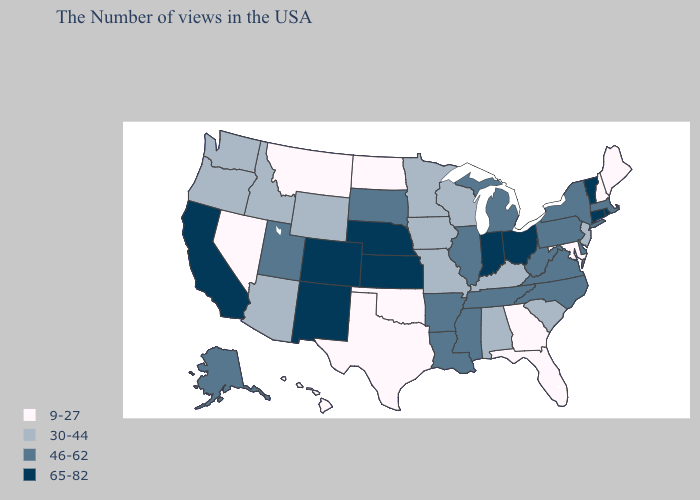What is the lowest value in the West?
Keep it brief. 9-27. Name the states that have a value in the range 46-62?
Write a very short answer. Massachusetts, New York, Delaware, Pennsylvania, Virginia, North Carolina, West Virginia, Michigan, Tennessee, Illinois, Mississippi, Louisiana, Arkansas, South Dakota, Utah, Alaska. Which states hav the highest value in the MidWest?
Keep it brief. Ohio, Indiana, Kansas, Nebraska. Name the states that have a value in the range 9-27?
Answer briefly. Maine, New Hampshire, Maryland, Florida, Georgia, Oklahoma, Texas, North Dakota, Montana, Nevada, Hawaii. What is the value of Wyoming?
Give a very brief answer. 30-44. Name the states that have a value in the range 65-82?
Answer briefly. Rhode Island, Vermont, Connecticut, Ohio, Indiana, Kansas, Nebraska, Colorado, New Mexico, California. Does Kansas have the highest value in the MidWest?
Write a very short answer. Yes. Which states have the lowest value in the USA?
Short answer required. Maine, New Hampshire, Maryland, Florida, Georgia, Oklahoma, Texas, North Dakota, Montana, Nevada, Hawaii. Does Michigan have a lower value than Colorado?
Answer briefly. Yes. Does Idaho have a lower value than California?
Be succinct. Yes. What is the highest value in the MidWest ?
Answer briefly. 65-82. Does Rhode Island have the highest value in the Northeast?
Answer briefly. Yes. Does Virginia have a higher value than Delaware?
Be succinct. No. Does Massachusetts have the lowest value in the USA?
Write a very short answer. No. 